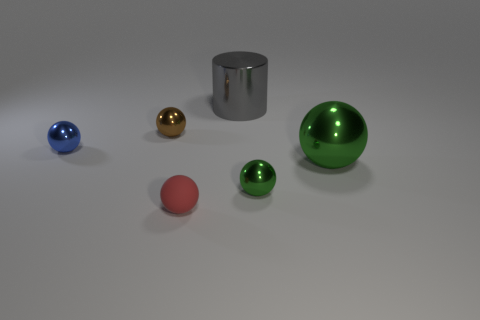There is a big metal object that is right of the gray metallic object; what shape is it?
Make the answer very short. Sphere. The green sphere left of the large shiny thing on the right side of the big shiny thing behind the blue metallic object is made of what material?
Offer a very short reply. Metal. What number of other things are the same size as the red matte thing?
Ensure brevity in your answer.  3. What is the material of the large green object that is the same shape as the small green object?
Provide a short and direct response. Metal. The cylinder has what color?
Give a very brief answer. Gray. There is a large thing that is right of the small metallic thing on the right side of the tiny brown object; what color is it?
Make the answer very short. Green. There is a cylinder; does it have the same color as the small metallic sphere to the right of the tiny red rubber object?
Provide a short and direct response. No. What number of small spheres are in front of the green shiny ball that is behind the small object right of the small matte object?
Provide a succinct answer. 2. Are there any tiny red balls on the left side of the brown metal ball?
Offer a terse response. No. Is there any other thing of the same color as the big cylinder?
Keep it short and to the point. No. 